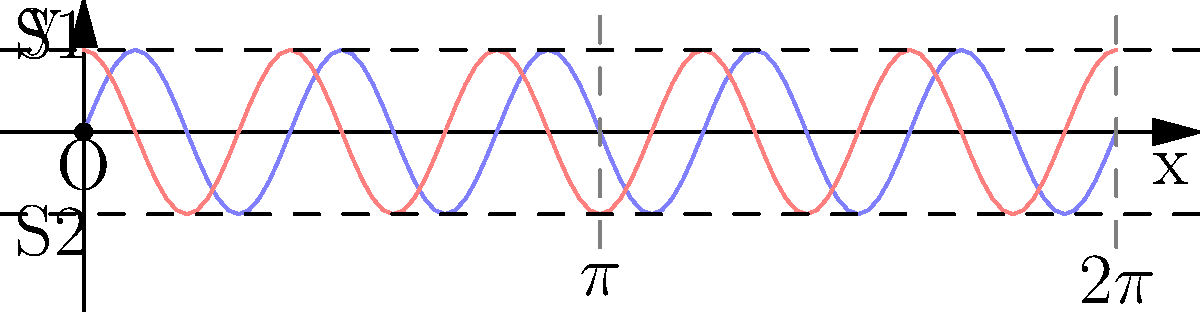In the double-slit experiment diagram shown above, two wave patterns (blue and red) are depicted emerging from slits S1 and S2. How does this representation help illustrate the wave-particle duality of light, and what key feature would you emphasize to a general audience to convey this concept effectively? To explain the wave-particle duality of light using this diagram, we can follow these steps:

1. Wave nature: The diagram shows two interfering wave patterns (blue and red) emerging from slits S1 and S2. This represents the wave-like behavior of light.

2. Interference pattern: The overlapping waves create an interference pattern, with areas of constructive (where waves align) and destructive (where waves cancel) interference.

3. Particle nature: Although not directly shown, individual photons (light particles) contribute to this pattern over time.

4. Probability distribution: The intensity of the interference pattern represents the probability of finding photons at different locations on the screen.

5. Key feature to emphasize: The interference pattern itself is crucial. It forms even when individual photons are sent through the slits one at a time, demonstrating both wave-like interference and particle-like behavior.

6. Analogy for general audience: Compare this to water waves passing through two openings, creating an interference pattern, but emphasize that light also arrives as individual "droplets" (photons) that build up this pattern over time.

7. Uncertainty principle: Mention that attempting to determine which slit a photon passes through destroys the interference pattern, illustrating the complementarity principle and the limits of simultaneous wave-particle knowledge.

To effectively communicate this concept, focus on the gradual buildup of the interference pattern by individual photons, emphasizing how this demonstrates both wave-like and particle-like properties simultaneously.
Answer: The interference pattern formed by individual photons demonstrates both wave-like (interference) and particle-like (discrete detection) properties of light simultaneously. 